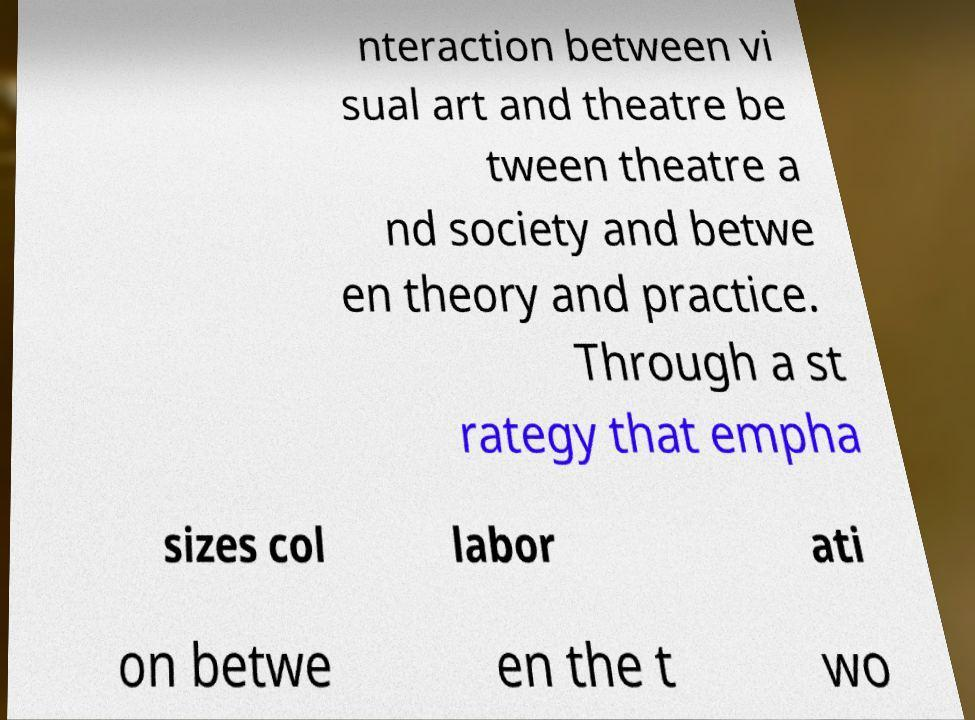There's text embedded in this image that I need extracted. Can you transcribe it verbatim? nteraction between vi sual art and theatre be tween theatre a nd society and betwe en theory and practice. Through a st rategy that empha sizes col labor ati on betwe en the t wo 